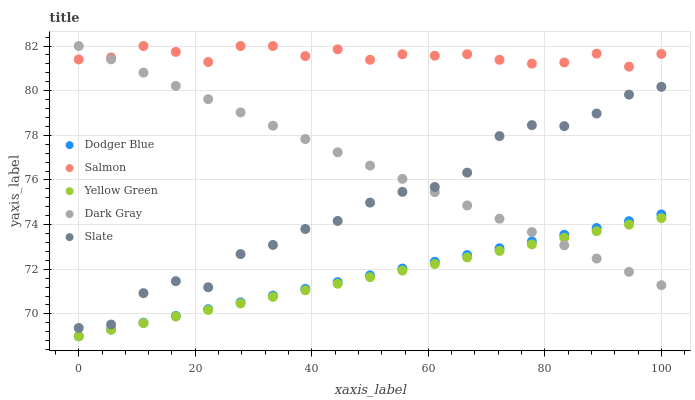Does Yellow Green have the minimum area under the curve?
Answer yes or no. Yes. Does Salmon have the maximum area under the curve?
Answer yes or no. Yes. Does Slate have the minimum area under the curve?
Answer yes or no. No. Does Slate have the maximum area under the curve?
Answer yes or no. No. Is Dodger Blue the smoothest?
Answer yes or no. Yes. Is Slate the roughest?
Answer yes or no. Yes. Is Salmon the smoothest?
Answer yes or no. No. Is Salmon the roughest?
Answer yes or no. No. Does Dodger Blue have the lowest value?
Answer yes or no. Yes. Does Slate have the lowest value?
Answer yes or no. No. Does Salmon have the highest value?
Answer yes or no. Yes. Does Slate have the highest value?
Answer yes or no. No. Is Dodger Blue less than Slate?
Answer yes or no. Yes. Is Slate greater than Yellow Green?
Answer yes or no. Yes. Does Dark Gray intersect Slate?
Answer yes or no. Yes. Is Dark Gray less than Slate?
Answer yes or no. No. Is Dark Gray greater than Slate?
Answer yes or no. No. Does Dodger Blue intersect Slate?
Answer yes or no. No. 